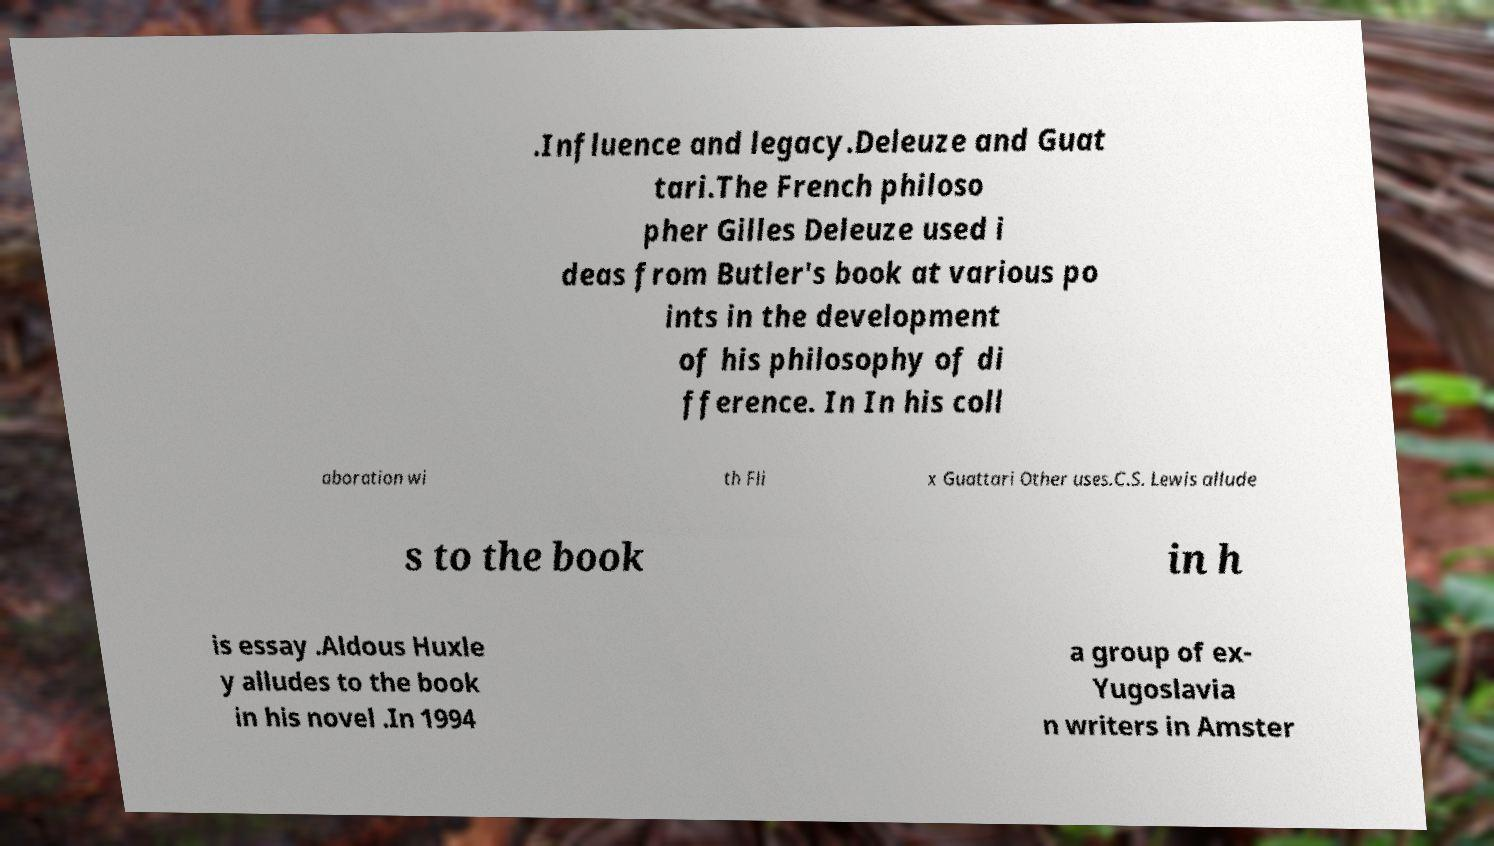Can you accurately transcribe the text from the provided image for me? .Influence and legacy.Deleuze and Guat tari.The French philoso pher Gilles Deleuze used i deas from Butler's book at various po ints in the development of his philosophy of di fference. In In his coll aboration wi th Fli x Guattari Other uses.C.S. Lewis allude s to the book in h is essay .Aldous Huxle y alludes to the book in his novel .In 1994 a group of ex- Yugoslavia n writers in Amster 